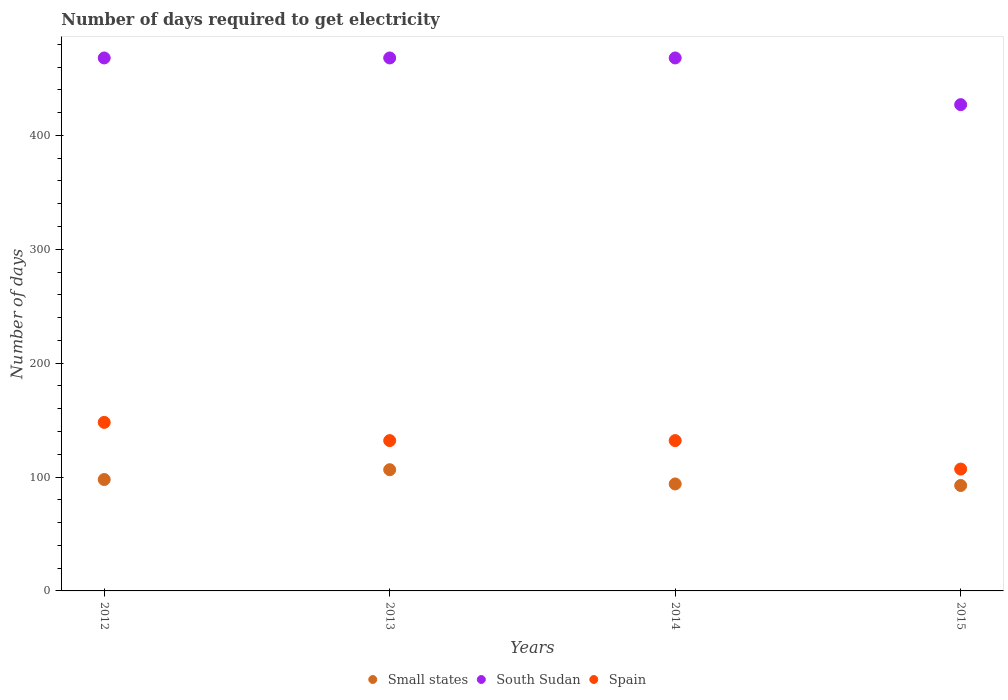Is the number of dotlines equal to the number of legend labels?
Provide a succinct answer. Yes. What is the number of days required to get electricity in in Spain in 2014?
Ensure brevity in your answer.  132. Across all years, what is the maximum number of days required to get electricity in in Small states?
Your answer should be very brief. 106.42. Across all years, what is the minimum number of days required to get electricity in in Small states?
Keep it short and to the point. 92.58. In which year was the number of days required to get electricity in in Small states maximum?
Give a very brief answer. 2013. In which year was the number of days required to get electricity in in South Sudan minimum?
Keep it short and to the point. 2015. What is the total number of days required to get electricity in in Small states in the graph?
Your response must be concise. 390.75. What is the difference between the number of days required to get electricity in in Small states in 2015 and the number of days required to get electricity in in Spain in 2012?
Keep it short and to the point. -55.42. What is the average number of days required to get electricity in in Spain per year?
Provide a succinct answer. 129.75. In the year 2013, what is the difference between the number of days required to get electricity in in Spain and number of days required to get electricity in in Small states?
Make the answer very short. 25.58. In how many years, is the number of days required to get electricity in in South Sudan greater than 20 days?
Offer a very short reply. 4. Is the difference between the number of days required to get electricity in in Spain in 2014 and 2015 greater than the difference between the number of days required to get electricity in in Small states in 2014 and 2015?
Your response must be concise. Yes. Is the sum of the number of days required to get electricity in in Spain in 2014 and 2015 greater than the maximum number of days required to get electricity in in Small states across all years?
Your answer should be compact. Yes. Does the number of days required to get electricity in in Small states monotonically increase over the years?
Ensure brevity in your answer.  No. Is the number of days required to get electricity in in South Sudan strictly greater than the number of days required to get electricity in in Spain over the years?
Keep it short and to the point. Yes. How many dotlines are there?
Give a very brief answer. 3. How many years are there in the graph?
Offer a very short reply. 4. What is the difference between two consecutive major ticks on the Y-axis?
Make the answer very short. 100. Are the values on the major ticks of Y-axis written in scientific E-notation?
Your answer should be compact. No. Where does the legend appear in the graph?
Offer a very short reply. Bottom center. What is the title of the graph?
Keep it short and to the point. Number of days required to get electricity. What is the label or title of the Y-axis?
Ensure brevity in your answer.  Number of days. What is the Number of days of Small states in 2012?
Make the answer very short. 97.83. What is the Number of days of South Sudan in 2012?
Provide a succinct answer. 468. What is the Number of days in Spain in 2012?
Offer a terse response. 148. What is the Number of days of Small states in 2013?
Make the answer very short. 106.42. What is the Number of days in South Sudan in 2013?
Ensure brevity in your answer.  468. What is the Number of days of Spain in 2013?
Provide a short and direct response. 132. What is the Number of days of Small states in 2014?
Your answer should be compact. 93.92. What is the Number of days of South Sudan in 2014?
Ensure brevity in your answer.  468. What is the Number of days in Spain in 2014?
Your response must be concise. 132. What is the Number of days of Small states in 2015?
Your answer should be very brief. 92.58. What is the Number of days in South Sudan in 2015?
Provide a short and direct response. 427. What is the Number of days of Spain in 2015?
Provide a succinct answer. 107. Across all years, what is the maximum Number of days in Small states?
Provide a succinct answer. 106.42. Across all years, what is the maximum Number of days in South Sudan?
Your answer should be compact. 468. Across all years, what is the maximum Number of days of Spain?
Your answer should be very brief. 148. Across all years, what is the minimum Number of days in Small states?
Make the answer very short. 92.58. Across all years, what is the minimum Number of days in South Sudan?
Give a very brief answer. 427. Across all years, what is the minimum Number of days in Spain?
Your response must be concise. 107. What is the total Number of days in Small states in the graph?
Keep it short and to the point. 390.75. What is the total Number of days in South Sudan in the graph?
Provide a succinct answer. 1831. What is the total Number of days in Spain in the graph?
Offer a terse response. 519. What is the difference between the Number of days of South Sudan in 2012 and that in 2013?
Keep it short and to the point. 0. What is the difference between the Number of days in South Sudan in 2012 and that in 2014?
Offer a very short reply. 0. What is the difference between the Number of days of Spain in 2012 and that in 2014?
Offer a very short reply. 16. What is the difference between the Number of days in Small states in 2012 and that in 2015?
Make the answer very short. 5.25. What is the difference between the Number of days of South Sudan in 2012 and that in 2015?
Make the answer very short. 41. What is the difference between the Number of days in Spain in 2012 and that in 2015?
Provide a short and direct response. 41. What is the difference between the Number of days of Small states in 2013 and that in 2014?
Your answer should be compact. 12.5. What is the difference between the Number of days in Small states in 2013 and that in 2015?
Give a very brief answer. 13.85. What is the difference between the Number of days in Spain in 2013 and that in 2015?
Your answer should be very brief. 25. What is the difference between the Number of days of Small states in 2014 and that in 2015?
Your answer should be compact. 1.35. What is the difference between the Number of days in South Sudan in 2014 and that in 2015?
Ensure brevity in your answer.  41. What is the difference between the Number of days of Small states in 2012 and the Number of days of South Sudan in 2013?
Keep it short and to the point. -370.18. What is the difference between the Number of days in Small states in 2012 and the Number of days in Spain in 2013?
Your response must be concise. -34.17. What is the difference between the Number of days of South Sudan in 2012 and the Number of days of Spain in 2013?
Provide a short and direct response. 336. What is the difference between the Number of days in Small states in 2012 and the Number of days in South Sudan in 2014?
Your response must be concise. -370.18. What is the difference between the Number of days of Small states in 2012 and the Number of days of Spain in 2014?
Your answer should be compact. -34.17. What is the difference between the Number of days in South Sudan in 2012 and the Number of days in Spain in 2014?
Keep it short and to the point. 336. What is the difference between the Number of days in Small states in 2012 and the Number of days in South Sudan in 2015?
Offer a very short reply. -329.18. What is the difference between the Number of days in Small states in 2012 and the Number of days in Spain in 2015?
Offer a terse response. -9.18. What is the difference between the Number of days in South Sudan in 2012 and the Number of days in Spain in 2015?
Provide a succinct answer. 361. What is the difference between the Number of days of Small states in 2013 and the Number of days of South Sudan in 2014?
Provide a short and direct response. -361.57. What is the difference between the Number of days in Small states in 2013 and the Number of days in Spain in 2014?
Your response must be concise. -25.57. What is the difference between the Number of days of South Sudan in 2013 and the Number of days of Spain in 2014?
Your answer should be very brief. 336. What is the difference between the Number of days in Small states in 2013 and the Number of days in South Sudan in 2015?
Your answer should be very brief. -320.57. What is the difference between the Number of days in Small states in 2013 and the Number of days in Spain in 2015?
Give a very brief answer. -0.57. What is the difference between the Number of days of South Sudan in 2013 and the Number of days of Spain in 2015?
Your response must be concise. 361. What is the difference between the Number of days in Small states in 2014 and the Number of days in South Sudan in 2015?
Ensure brevity in your answer.  -333.07. What is the difference between the Number of days in Small states in 2014 and the Number of days in Spain in 2015?
Provide a short and direct response. -13.07. What is the difference between the Number of days in South Sudan in 2014 and the Number of days in Spain in 2015?
Give a very brief answer. 361. What is the average Number of days of Small states per year?
Provide a succinct answer. 97.69. What is the average Number of days of South Sudan per year?
Your response must be concise. 457.75. What is the average Number of days in Spain per year?
Offer a terse response. 129.75. In the year 2012, what is the difference between the Number of days of Small states and Number of days of South Sudan?
Your answer should be compact. -370.18. In the year 2012, what is the difference between the Number of days in Small states and Number of days in Spain?
Your response must be concise. -50.17. In the year 2012, what is the difference between the Number of days of South Sudan and Number of days of Spain?
Ensure brevity in your answer.  320. In the year 2013, what is the difference between the Number of days of Small states and Number of days of South Sudan?
Make the answer very short. -361.57. In the year 2013, what is the difference between the Number of days of Small states and Number of days of Spain?
Provide a short and direct response. -25.57. In the year 2013, what is the difference between the Number of days of South Sudan and Number of days of Spain?
Offer a terse response. 336. In the year 2014, what is the difference between the Number of days of Small states and Number of days of South Sudan?
Ensure brevity in your answer.  -374.07. In the year 2014, what is the difference between the Number of days in Small states and Number of days in Spain?
Your answer should be compact. -38.08. In the year 2014, what is the difference between the Number of days in South Sudan and Number of days in Spain?
Offer a very short reply. 336. In the year 2015, what is the difference between the Number of days of Small states and Number of days of South Sudan?
Your answer should be compact. -334.43. In the year 2015, what is the difference between the Number of days in Small states and Number of days in Spain?
Offer a very short reply. -14.43. In the year 2015, what is the difference between the Number of days of South Sudan and Number of days of Spain?
Your answer should be compact. 320. What is the ratio of the Number of days of Small states in 2012 to that in 2013?
Keep it short and to the point. 0.92. What is the ratio of the Number of days in Spain in 2012 to that in 2013?
Ensure brevity in your answer.  1.12. What is the ratio of the Number of days of Small states in 2012 to that in 2014?
Your answer should be compact. 1.04. What is the ratio of the Number of days in Spain in 2012 to that in 2014?
Offer a terse response. 1.12. What is the ratio of the Number of days in Small states in 2012 to that in 2015?
Make the answer very short. 1.06. What is the ratio of the Number of days of South Sudan in 2012 to that in 2015?
Your response must be concise. 1.1. What is the ratio of the Number of days of Spain in 2012 to that in 2015?
Your response must be concise. 1.38. What is the ratio of the Number of days of Small states in 2013 to that in 2014?
Your answer should be very brief. 1.13. What is the ratio of the Number of days of Small states in 2013 to that in 2015?
Provide a short and direct response. 1.15. What is the ratio of the Number of days of South Sudan in 2013 to that in 2015?
Offer a terse response. 1.1. What is the ratio of the Number of days in Spain in 2013 to that in 2015?
Ensure brevity in your answer.  1.23. What is the ratio of the Number of days in Small states in 2014 to that in 2015?
Offer a very short reply. 1.01. What is the ratio of the Number of days of South Sudan in 2014 to that in 2015?
Provide a succinct answer. 1.1. What is the ratio of the Number of days in Spain in 2014 to that in 2015?
Your answer should be compact. 1.23. What is the difference between the highest and the second highest Number of days of Small states?
Make the answer very short. 8.6. What is the difference between the highest and the second highest Number of days of South Sudan?
Give a very brief answer. 0. What is the difference between the highest and the second highest Number of days in Spain?
Offer a terse response. 16. What is the difference between the highest and the lowest Number of days in Small states?
Provide a succinct answer. 13.85. What is the difference between the highest and the lowest Number of days of South Sudan?
Offer a terse response. 41. What is the difference between the highest and the lowest Number of days of Spain?
Ensure brevity in your answer.  41. 